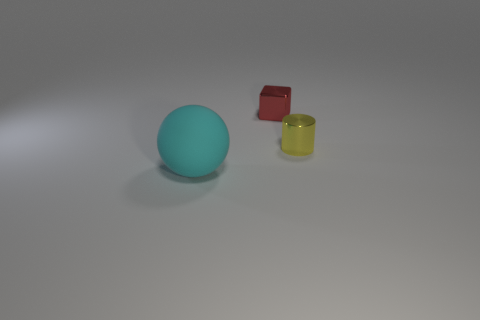There is a object that is on the left side of the metal thing that is behind the metallic cylinder; what size is it?
Offer a terse response. Large. What is the color of the thing that is on the right side of the large ball and on the left side of the cylinder?
Provide a succinct answer. Red. How many other objects are there of the same shape as the yellow shiny object?
Make the answer very short. 0. The thing that is the same size as the metallic cylinder is what color?
Provide a succinct answer. Red. There is a thing to the right of the red block; what is its color?
Provide a succinct answer. Yellow. Are there any tiny things that are behind the shiny thing that is in front of the red object?
Your response must be concise. Yes. There is a cyan thing; is it the same shape as the tiny metal thing that is behind the yellow thing?
Offer a terse response. No. What is the size of the object that is in front of the small metal block and on the left side of the small yellow thing?
Provide a short and direct response. Large. Is there another cyan sphere that has the same material as the large cyan ball?
Your answer should be very brief. No. There is a thing that is in front of the thing that is right of the metallic cube; what is it made of?
Your response must be concise. Rubber. 